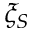<formula> <loc_0><loc_0><loc_500><loc_500>\xi _ { S }</formula> 